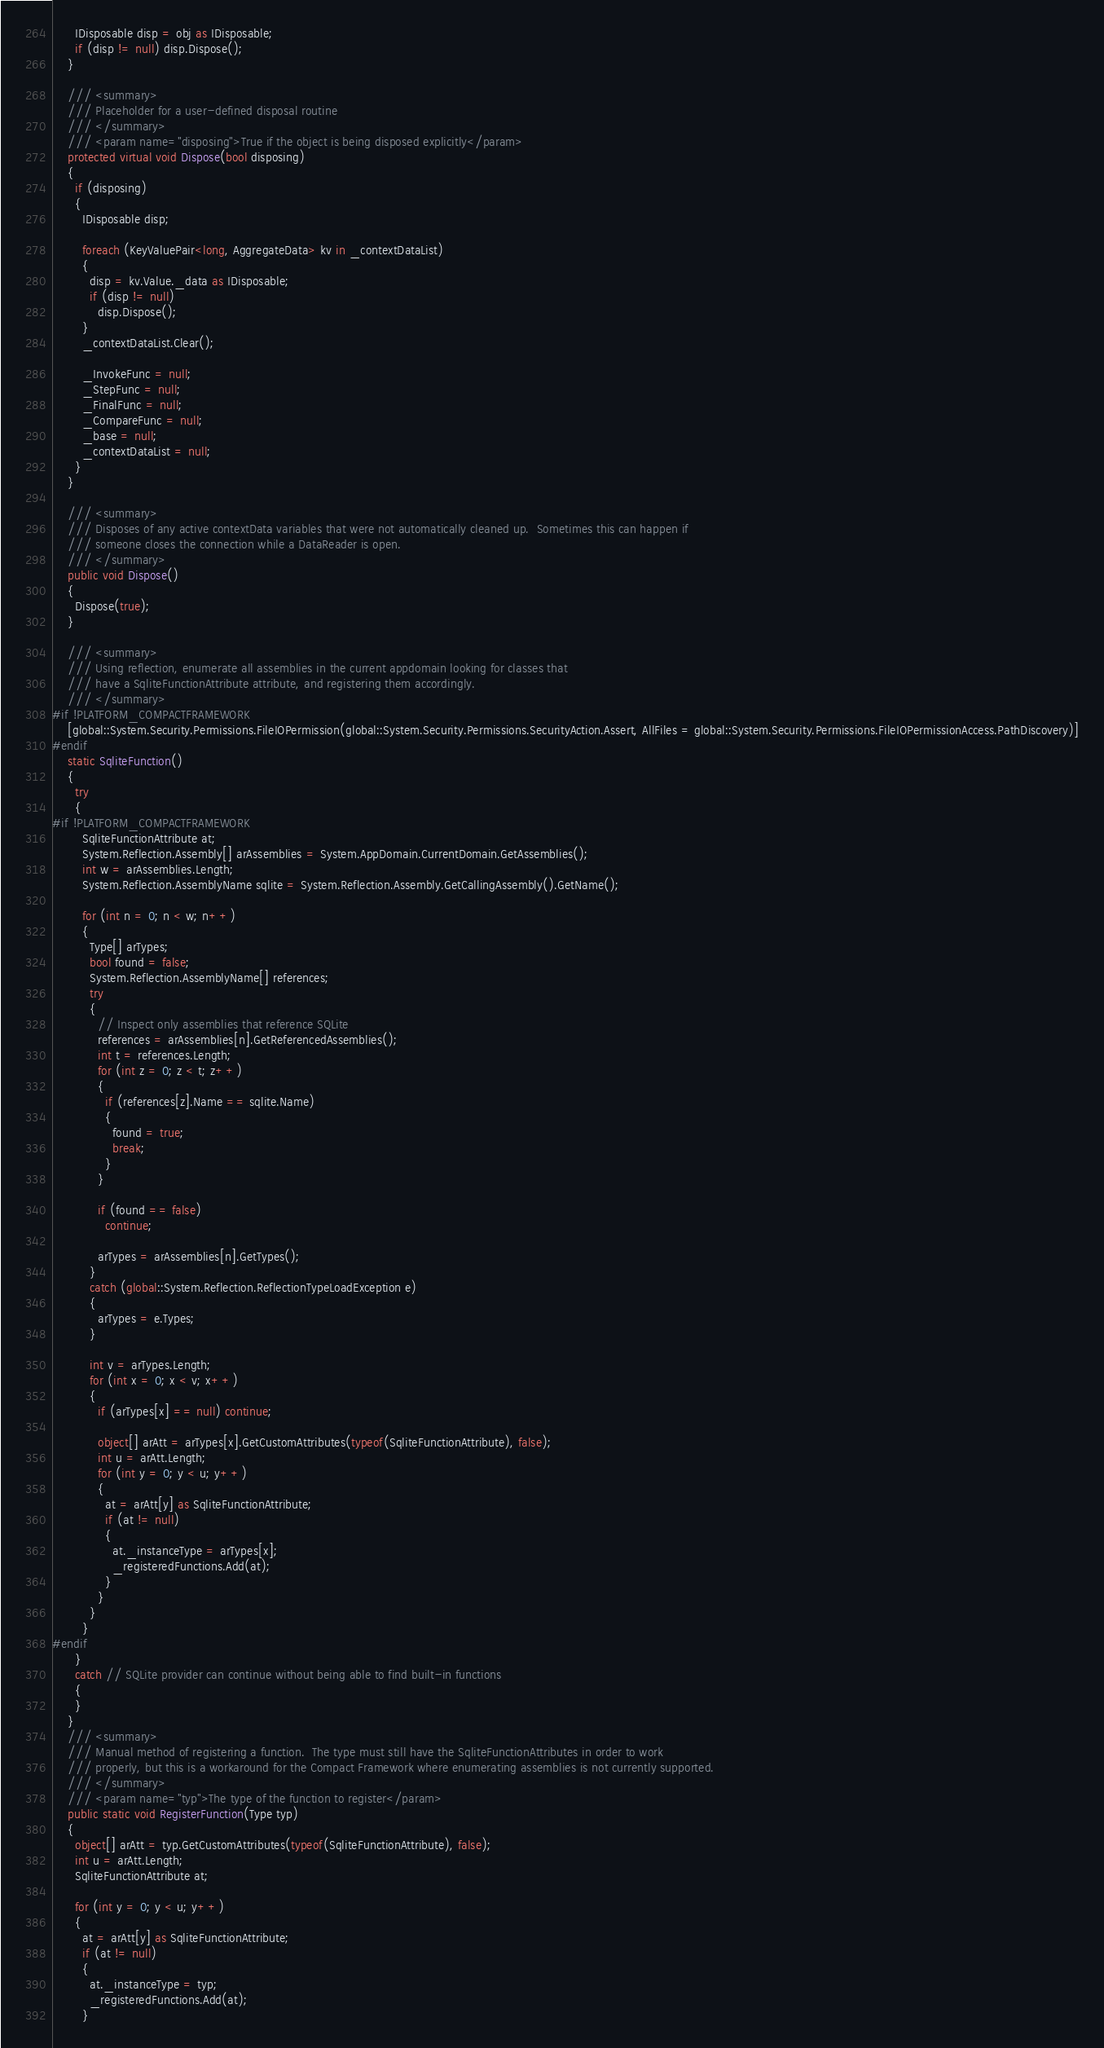Convert code to text. <code><loc_0><loc_0><loc_500><loc_500><_C#_>
      IDisposable disp = obj as IDisposable;
      if (disp != null) disp.Dispose();
    }

    /// <summary>
    /// Placeholder for a user-defined disposal routine
    /// </summary>
    /// <param name="disposing">True if the object is being disposed explicitly</param>
    protected virtual void Dispose(bool disposing)
    {
      if (disposing)
      {
        IDisposable disp;

        foreach (KeyValuePair<long, AggregateData> kv in _contextDataList)
        {
          disp = kv.Value._data as IDisposable;
          if (disp != null)
            disp.Dispose();
        }
        _contextDataList.Clear();

        _InvokeFunc = null;
        _StepFunc = null;
        _FinalFunc = null;
        _CompareFunc = null;
        _base = null;
        _contextDataList = null;
      }
    }

    /// <summary>
    /// Disposes of any active contextData variables that were not automatically cleaned up.  Sometimes this can happen if
    /// someone closes the connection while a DataReader is open.
    /// </summary>
    public void Dispose()
    {
      Dispose(true);
    }

    /// <summary>
    /// Using reflection, enumerate all assemblies in the current appdomain looking for classes that
    /// have a SqliteFunctionAttribute attribute, and registering them accordingly.
    /// </summary>
#if !PLATFORM_COMPACTFRAMEWORK
    [global::System.Security.Permissions.FileIOPermission(global::System.Security.Permissions.SecurityAction.Assert, AllFiles = global::System.Security.Permissions.FileIOPermissionAccess.PathDiscovery)]
#endif
    static SqliteFunction()
    {
      try
      {
#if !PLATFORM_COMPACTFRAMEWORK
        SqliteFunctionAttribute at;
        System.Reflection.Assembly[] arAssemblies = System.AppDomain.CurrentDomain.GetAssemblies();
        int w = arAssemblies.Length;
        System.Reflection.AssemblyName sqlite = System.Reflection.Assembly.GetCallingAssembly().GetName();

        for (int n = 0; n < w; n++)
        {
          Type[] arTypes;
          bool found = false;
          System.Reflection.AssemblyName[] references;
          try
          {
            // Inspect only assemblies that reference SQLite
            references = arAssemblies[n].GetReferencedAssemblies();
            int t = references.Length;
            for (int z = 0; z < t; z++)
            {
              if (references[z].Name == sqlite.Name)
              {
                found = true;
                break;
              }
            }

            if (found == false)
              continue;

            arTypes = arAssemblies[n].GetTypes();
          }
          catch (global::System.Reflection.ReflectionTypeLoadException e)
          {
            arTypes = e.Types;
          }

          int v = arTypes.Length;
          for (int x = 0; x < v; x++)
          {
            if (arTypes[x] == null) continue;

            object[] arAtt = arTypes[x].GetCustomAttributes(typeof(SqliteFunctionAttribute), false);
            int u = arAtt.Length;
            for (int y = 0; y < u; y++)
            {
              at = arAtt[y] as SqliteFunctionAttribute;
              if (at != null)
              {
                at._instanceType = arTypes[x];
                _registeredFunctions.Add(at);
              }
            }
          }
        }
#endif
      }
      catch // SQLite provider can continue without being able to find built-in functions
      {
      }
    }
    /// <summary>
    /// Manual method of registering a function.  The type must still have the SqliteFunctionAttributes in order to work
    /// properly, but this is a workaround for the Compact Framework where enumerating assemblies is not currently supported.
    /// </summary>
    /// <param name="typ">The type of the function to register</param>
    public static void RegisterFunction(Type typ)
    {
      object[] arAtt = typ.GetCustomAttributes(typeof(SqliteFunctionAttribute), false);
      int u = arAtt.Length;
      SqliteFunctionAttribute at;

      for (int y = 0; y < u; y++)
      {
        at = arAtt[y] as SqliteFunctionAttribute;
        if (at != null)
        {
          at._instanceType = typ;
          _registeredFunctions.Add(at);
        }</code> 